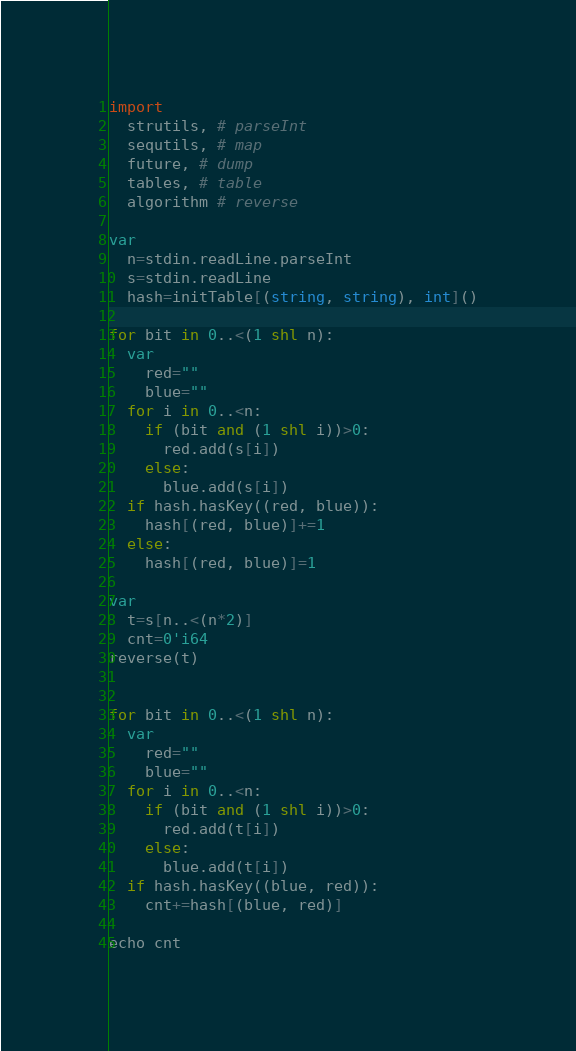Convert code to text. <code><loc_0><loc_0><loc_500><loc_500><_Nim_>import 
  strutils, # parseInt
  sequtils, # map
  future, # dump
  tables, # table
  algorithm # reverse

var 
  n=stdin.readLine.parseInt
  s=stdin.readLine
  hash=initTable[(string, string), int]()

for bit in 0..<(1 shl n):
  var 
    red=""
    blue=""
  for i in 0..<n:
    if (bit and (1 shl i))>0:
      red.add(s[i])
    else:
      blue.add(s[i])
  if hash.hasKey((red, blue)):
    hash[(red, blue)]+=1
  else:
    hash[(red, blue)]=1

var 
  t=s[n..<(n*2)]
  cnt=0'i64
reverse(t)


for bit in 0..<(1 shl n):
  var 
    red=""
    blue=""
  for i in 0..<n:
    if (bit and (1 shl i))>0:
      red.add(t[i])
    else:
      blue.add(t[i])
  if hash.hasKey((blue, red)):
    cnt+=hash[(blue, red)]

echo cnt</code> 